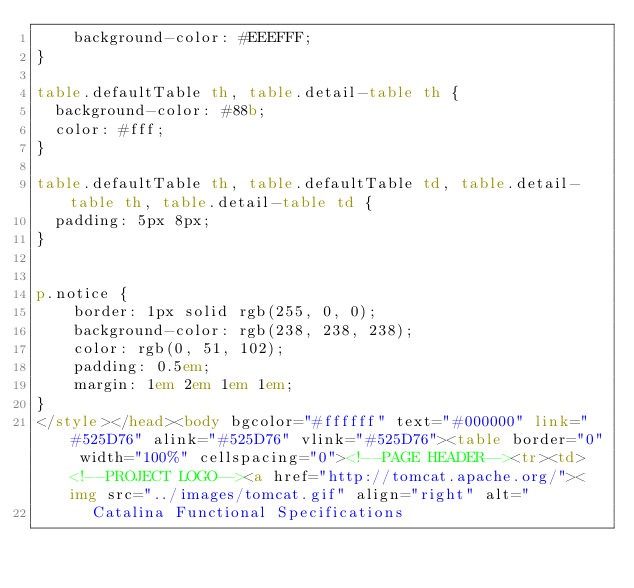Convert code to text. <code><loc_0><loc_0><loc_500><loc_500><_HTML_>    background-color: #EEEFFF;
}

table.defaultTable th, table.detail-table th {
  background-color: #88b;
  color: #fff;
}

table.defaultTable th, table.defaultTable td, table.detail-table th, table.detail-table td {
  padding: 5px 8px;
}


p.notice {
    border: 1px solid rgb(255, 0, 0);
    background-color: rgb(238, 238, 238);
    color: rgb(0, 51, 102);
    padding: 0.5em;
    margin: 1em 2em 1em 1em;
}
</style></head><body bgcolor="#ffffff" text="#000000" link="#525D76" alink="#525D76" vlink="#525D76"><table border="0" width="100%" cellspacing="0"><!--PAGE HEADER--><tr><td><!--PROJECT LOGO--><a href="http://tomcat.apache.org/"><img src="../images/tomcat.gif" align="right" alt="
      Catalina Functional Specifications</code> 